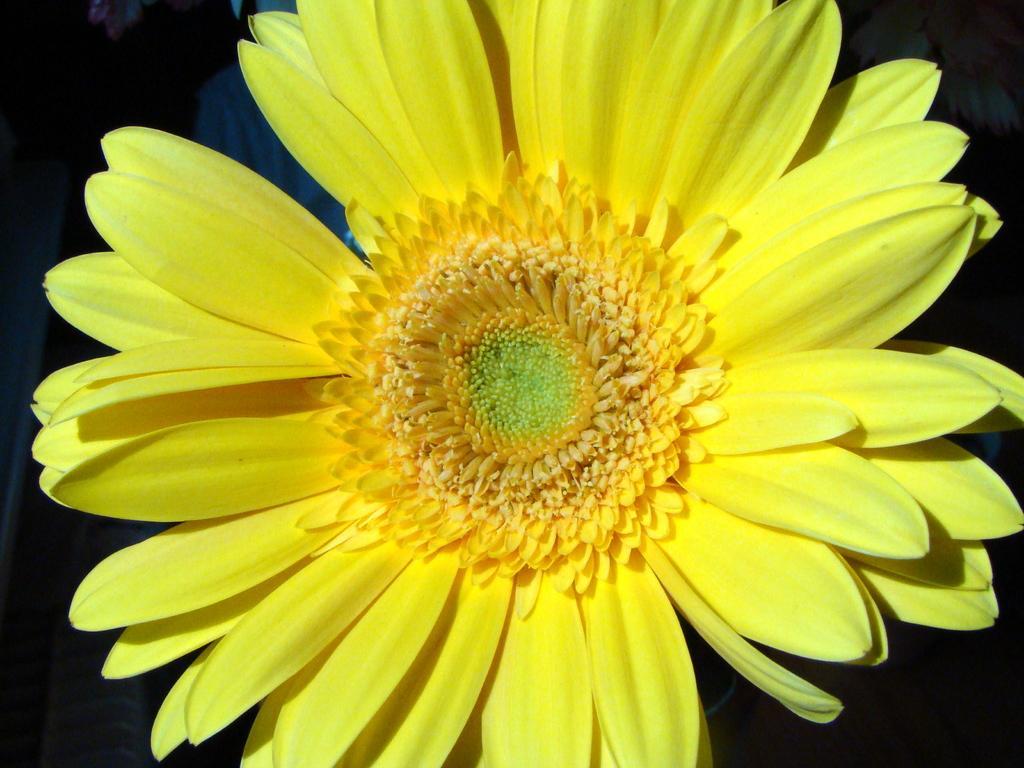Could you give a brief overview of what you see in this image? In this image we can see a flower. 